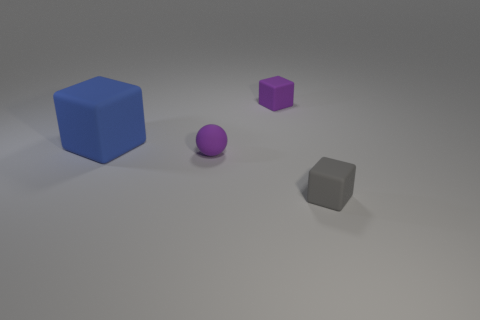What number of other purple cubes are the same size as the purple rubber block?
Offer a very short reply. 0. Does the ball have the same size as the matte cube that is in front of the blue rubber thing?
Provide a succinct answer. Yes. How many things are either rubber balls or tiny purple matte blocks?
Provide a succinct answer. 2. How many big matte cubes have the same color as the large object?
Offer a very short reply. 0. There is a purple thing that is the same size as the purple cube; what shape is it?
Offer a very short reply. Sphere. Are there any large brown rubber objects of the same shape as the small gray thing?
Your response must be concise. No. What number of blocks are made of the same material as the small gray thing?
Provide a succinct answer. 2. Is the cube that is to the right of the purple block made of the same material as the large blue object?
Your answer should be compact. Yes. Is the number of purple objects that are in front of the blue matte thing greater than the number of large matte things that are in front of the tiny rubber ball?
Make the answer very short. Yes. What material is the gray thing that is the same size as the purple rubber ball?
Your answer should be very brief. Rubber. 